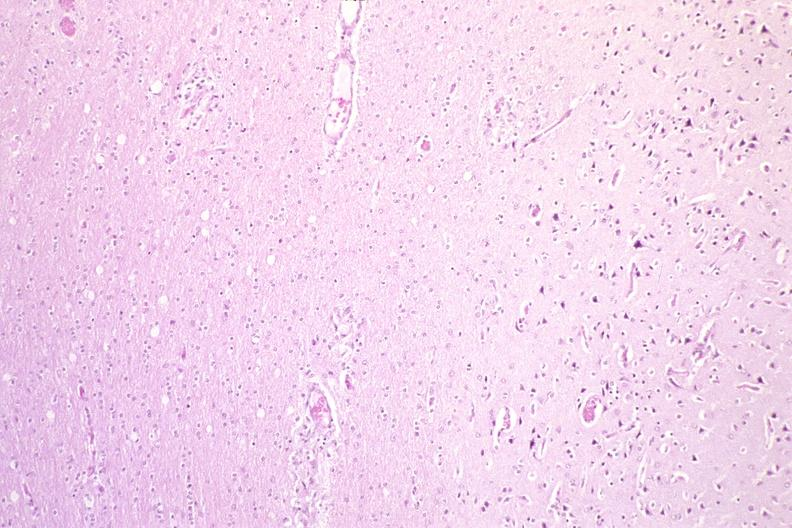what is present?
Answer the question using a single word or phrase. Nervous 